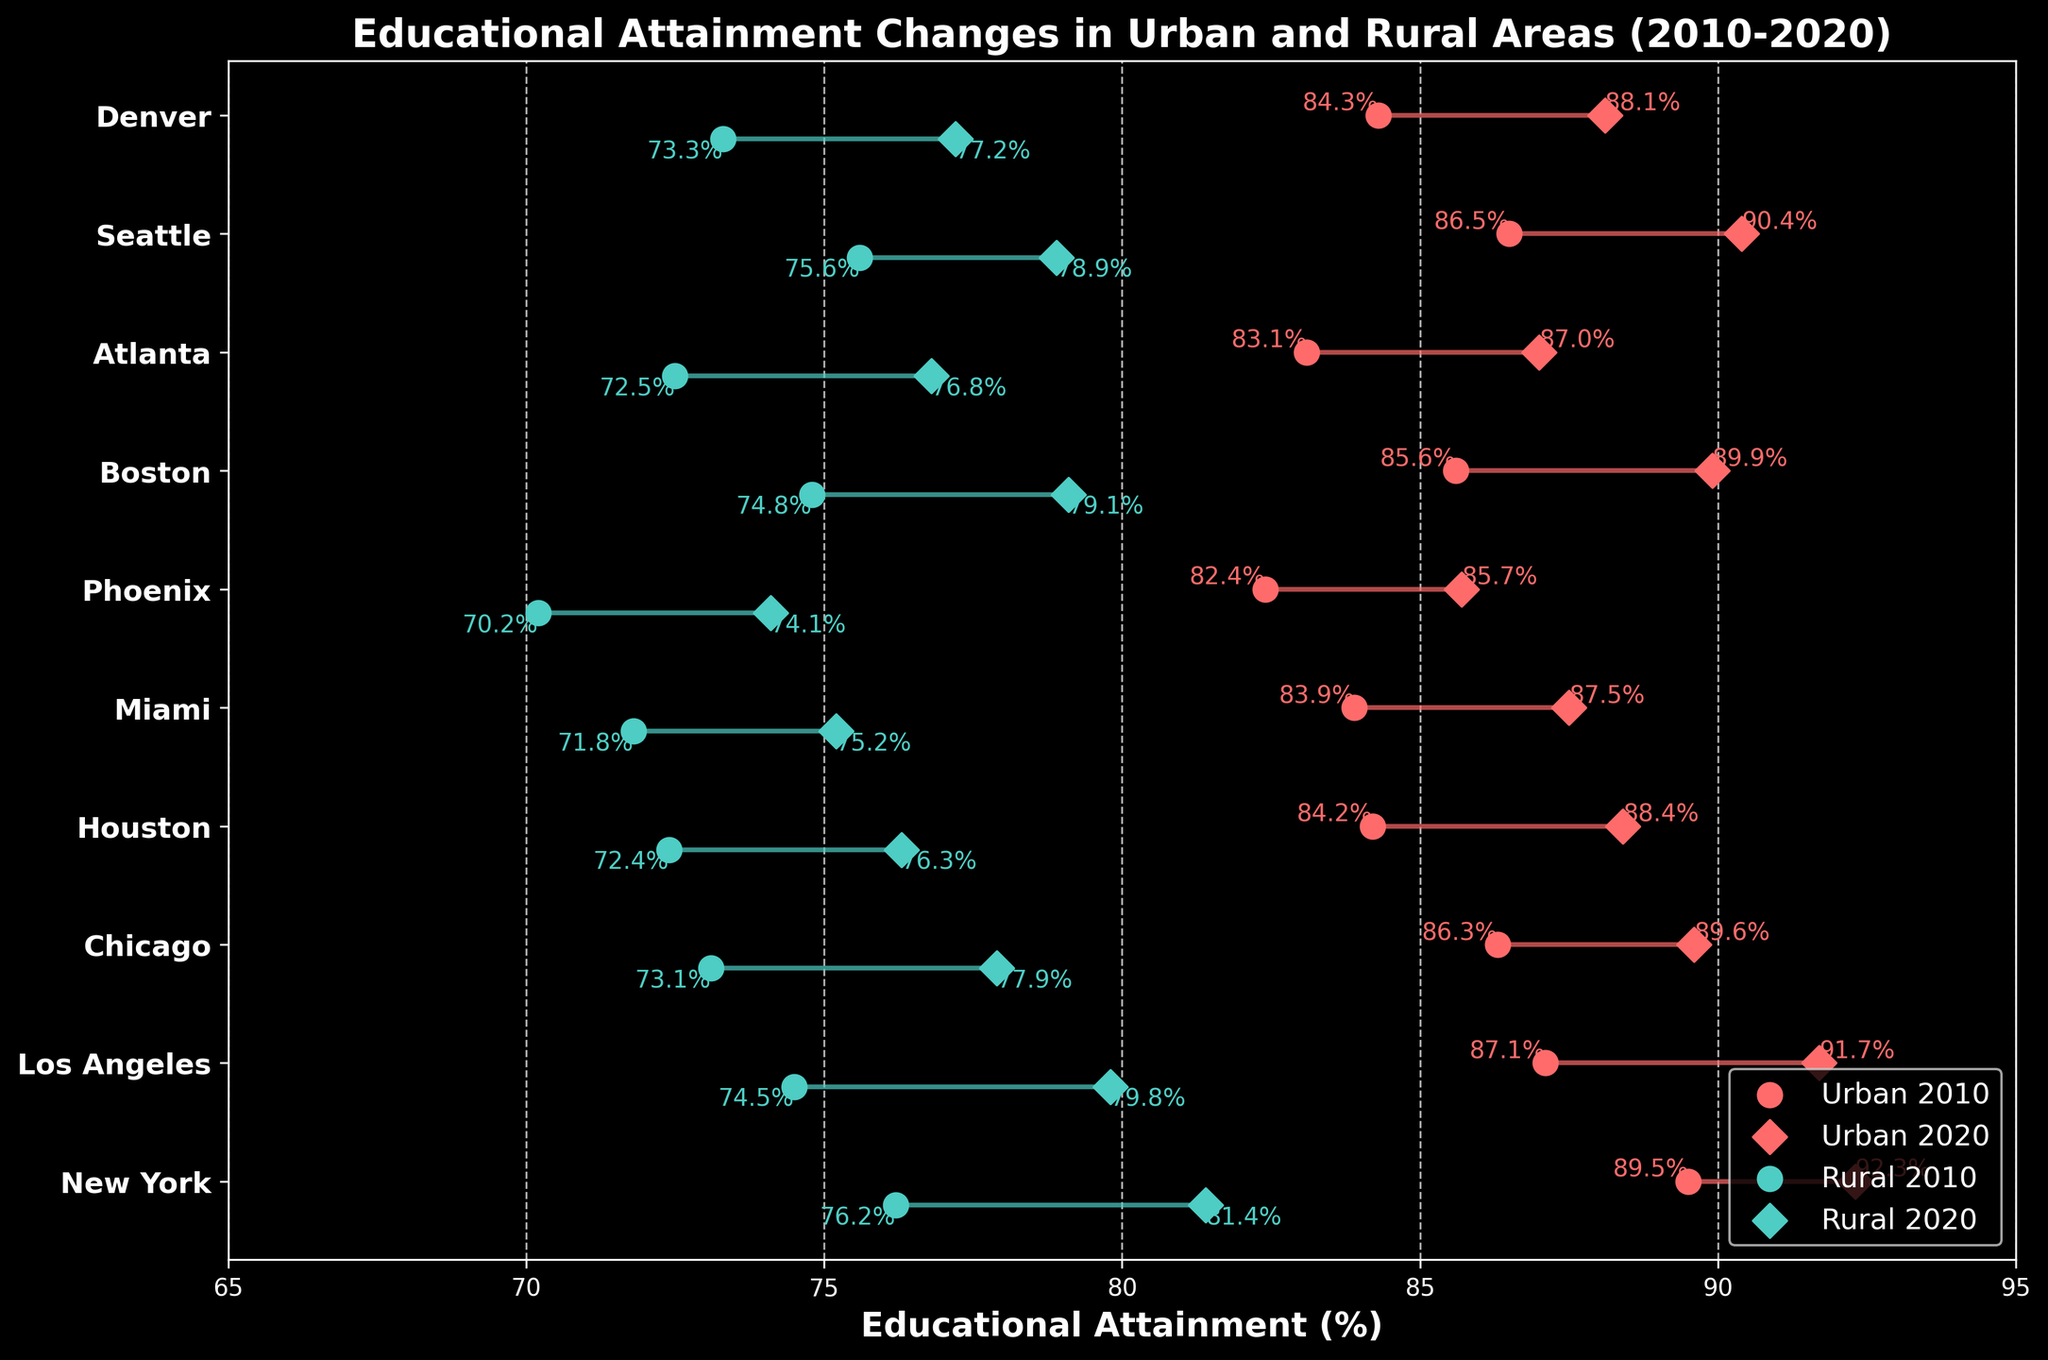what is the title of the plot? The title is found at the top of the plot and it provides a descriptive summary of what the plot is about. In this case, the title is "Educational Attainment Changes in Urban and Rural Areas (2010-2020)"
Answer: Educational Attainment Changes in Urban and Rural Areas (2010-2020) what color represents urban data points? By looking at the description in the legend and the color of the markers, the urban data points are represented in red.
Answer: red how many locations are compared in the plot? By counting the number of different labeled ticks on the y-axis, we see there are 10 locations compared in the plot.
Answer: 10 what is the highest educational attainment percentage for rural areas in 2020? The rural 2020 percentages are marked by diamond shapes in green. The highest value is next to the location New York, which is 81.4%.
Answer: 81.4% which location shows the greatest increase in urban educational attainment between 2010 and 2020? By comparing the gap between the urban 2010 and urban 2020 points for each location, Los Angeles shows the largest increase. The values change from 87.1% to 91.7%, an increase of 4.6%.
Answer: Los Angeles what is the difference between urban and rural educational attainment in Chicago for 2020? Urban 2020 for Chicago is 89.6%, and Rural 2020 is 77.9%. The difference is 89.6% - 77.9% = 11.7%.
Answer: 11.7% what is the average educational attainment in rural areas for 2020? The rural 2020 values are 81.4, 79.8, 77.9, 76.3, 75.2, 74.1, 79.1, 76.8, 78.9, 77.2. The sum is 776.7. To find the average, divide by 10, so 776.7 / 10 = 77.67%.
Answer: 77.67% which location had the smallest change in urban educational attainment from 2010 to 2020? By comparing the differences for each location, Phoenix had the smallest change from 82.4% to 85.7%, an increase of 3.3%.
Answer: Phoenix do urban or rural areas show more improvement in educational attainment overall from 2010 to 2020? Calculate the average increase for urban (group all urban increases) and rural areas (group all rural increases). Urban increases average to 4.1% across all cities, while rural increases average to 4.76%. Thus, rural areas show more overall improvement.
Answer: rural which location had the highest educational attainment in urban areas in 2020? The urban 2020 values are indicated by diamonds in red. Among these, New York has the highest value at 92.3%.
Answer: New York 